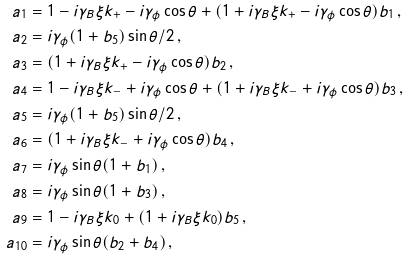<formula> <loc_0><loc_0><loc_500><loc_500>a _ { 1 } & = 1 - i \gamma _ { B } \xi k _ { + } - i \gamma _ { \phi } \cos \theta + ( 1 + i \gamma _ { B } \xi k _ { + } - i \gamma _ { \phi } \cos \theta ) b _ { 1 } \, , \\ a _ { 2 } & = i \gamma _ { \phi } ( 1 + b _ { 5 } ) \sin \theta / 2 \, , \\ a _ { 3 } & = ( 1 + i \gamma _ { B } \xi k _ { + } - i \gamma _ { \phi } \cos \theta ) b _ { 2 } \, , \\ a _ { 4 } & = 1 - i \gamma _ { B } \xi k _ { - } + i \gamma _ { \phi } \cos \theta + ( 1 + i \gamma _ { B } \xi k _ { - } + i \gamma _ { \phi } \cos \theta ) b _ { 3 } \, , \\ a _ { 5 } & = i \gamma _ { \phi } ( 1 + b _ { 5 } ) \sin \theta / 2 \, , \\ a _ { 6 } & = ( 1 + i \gamma _ { B } \xi k _ { - } + i \gamma _ { \phi } \cos \theta ) b _ { 4 } \, , \\ a _ { 7 } & = i \gamma _ { \phi } \sin \theta ( 1 + b _ { 1 } ) \, , \\ a _ { 8 } & = i \gamma _ { \phi } \sin \theta ( 1 + b _ { 3 } ) \, , \\ a _ { 9 } & = 1 - i \gamma _ { B } \xi k _ { 0 } + ( 1 + i \gamma _ { B } \xi k _ { 0 } ) b _ { 5 } \, , \\ a _ { 1 0 } & = i \gamma _ { \phi } \sin \theta ( b _ { 2 } + b _ { 4 } ) \, ,</formula> 